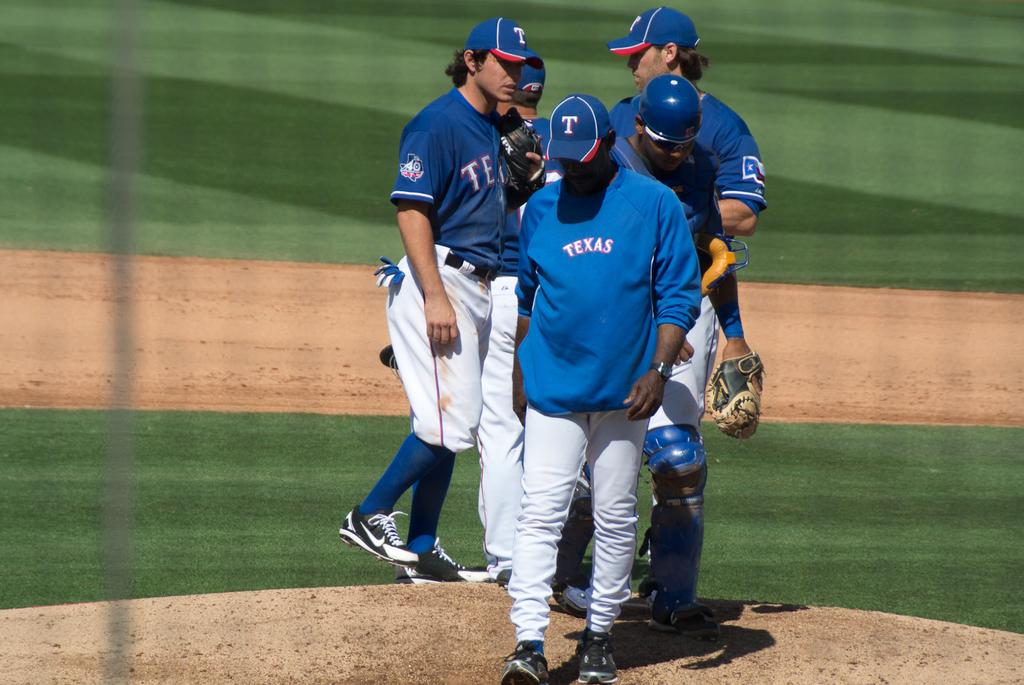<image>
Create a compact narrative representing the image presented. TEXAS is the name written on the shirts team in blue. 